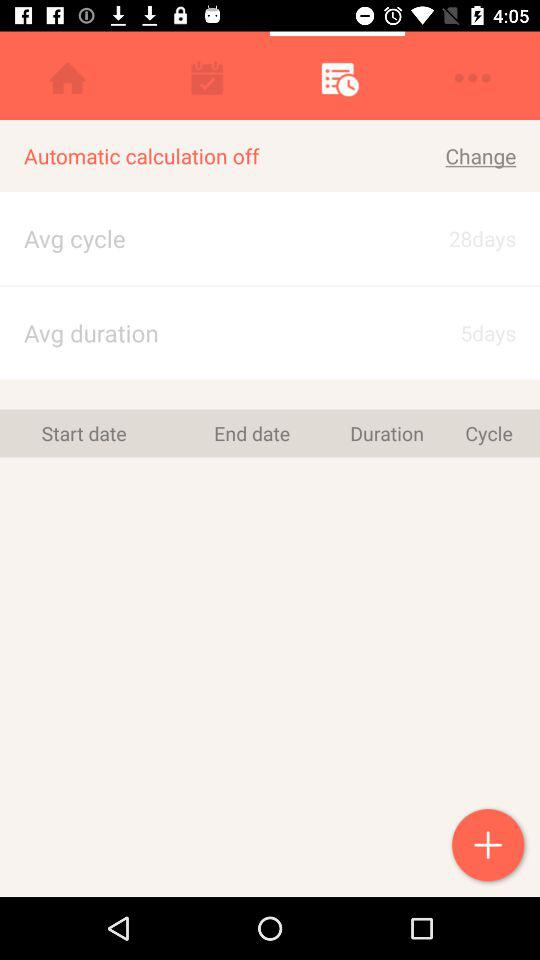How many days are there in an average cycle? There are 28 days in an average cycle. 